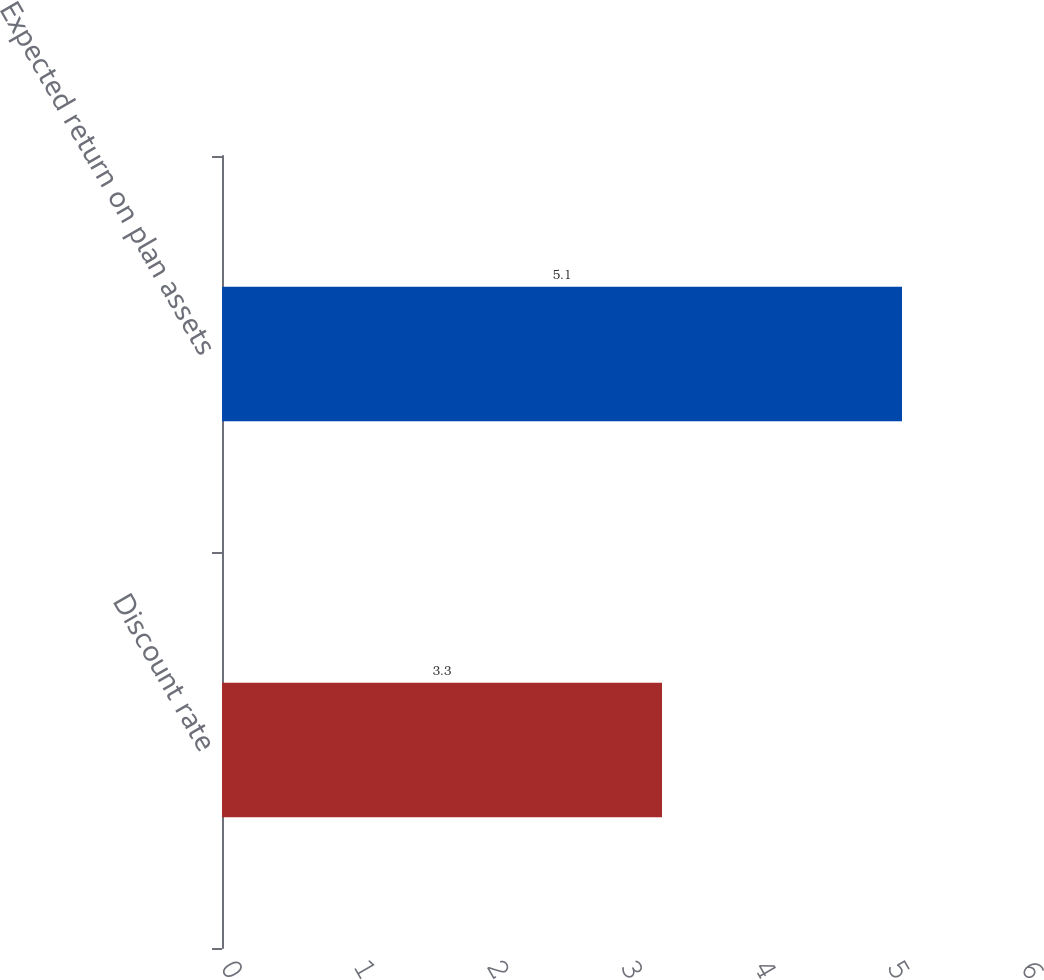Convert chart to OTSL. <chart><loc_0><loc_0><loc_500><loc_500><bar_chart><fcel>Discount rate<fcel>Expected return on plan assets<nl><fcel>3.3<fcel>5.1<nl></chart> 